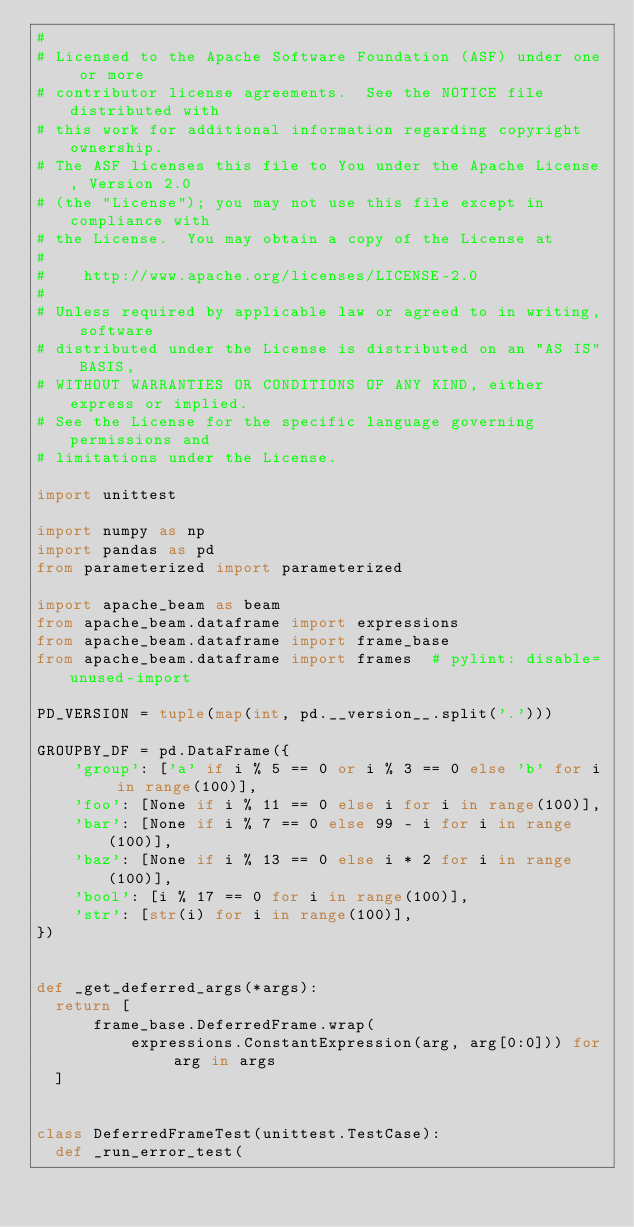<code> <loc_0><loc_0><loc_500><loc_500><_Python_>#
# Licensed to the Apache Software Foundation (ASF) under one or more
# contributor license agreements.  See the NOTICE file distributed with
# this work for additional information regarding copyright ownership.
# The ASF licenses this file to You under the Apache License, Version 2.0
# (the "License"); you may not use this file except in compliance with
# the License.  You may obtain a copy of the License at
#
#    http://www.apache.org/licenses/LICENSE-2.0
#
# Unless required by applicable law or agreed to in writing, software
# distributed under the License is distributed on an "AS IS" BASIS,
# WITHOUT WARRANTIES OR CONDITIONS OF ANY KIND, either express or implied.
# See the License for the specific language governing permissions and
# limitations under the License.

import unittest

import numpy as np
import pandas as pd
from parameterized import parameterized

import apache_beam as beam
from apache_beam.dataframe import expressions
from apache_beam.dataframe import frame_base
from apache_beam.dataframe import frames  # pylint: disable=unused-import

PD_VERSION = tuple(map(int, pd.__version__.split('.')))

GROUPBY_DF = pd.DataFrame({
    'group': ['a' if i % 5 == 0 or i % 3 == 0 else 'b' for i in range(100)],
    'foo': [None if i % 11 == 0 else i for i in range(100)],
    'bar': [None if i % 7 == 0 else 99 - i for i in range(100)],
    'baz': [None if i % 13 == 0 else i * 2 for i in range(100)],
    'bool': [i % 17 == 0 for i in range(100)],
    'str': [str(i) for i in range(100)],
})


def _get_deferred_args(*args):
  return [
      frame_base.DeferredFrame.wrap(
          expressions.ConstantExpression(arg, arg[0:0])) for arg in args
  ]


class DeferredFrameTest(unittest.TestCase):
  def _run_error_test(</code> 